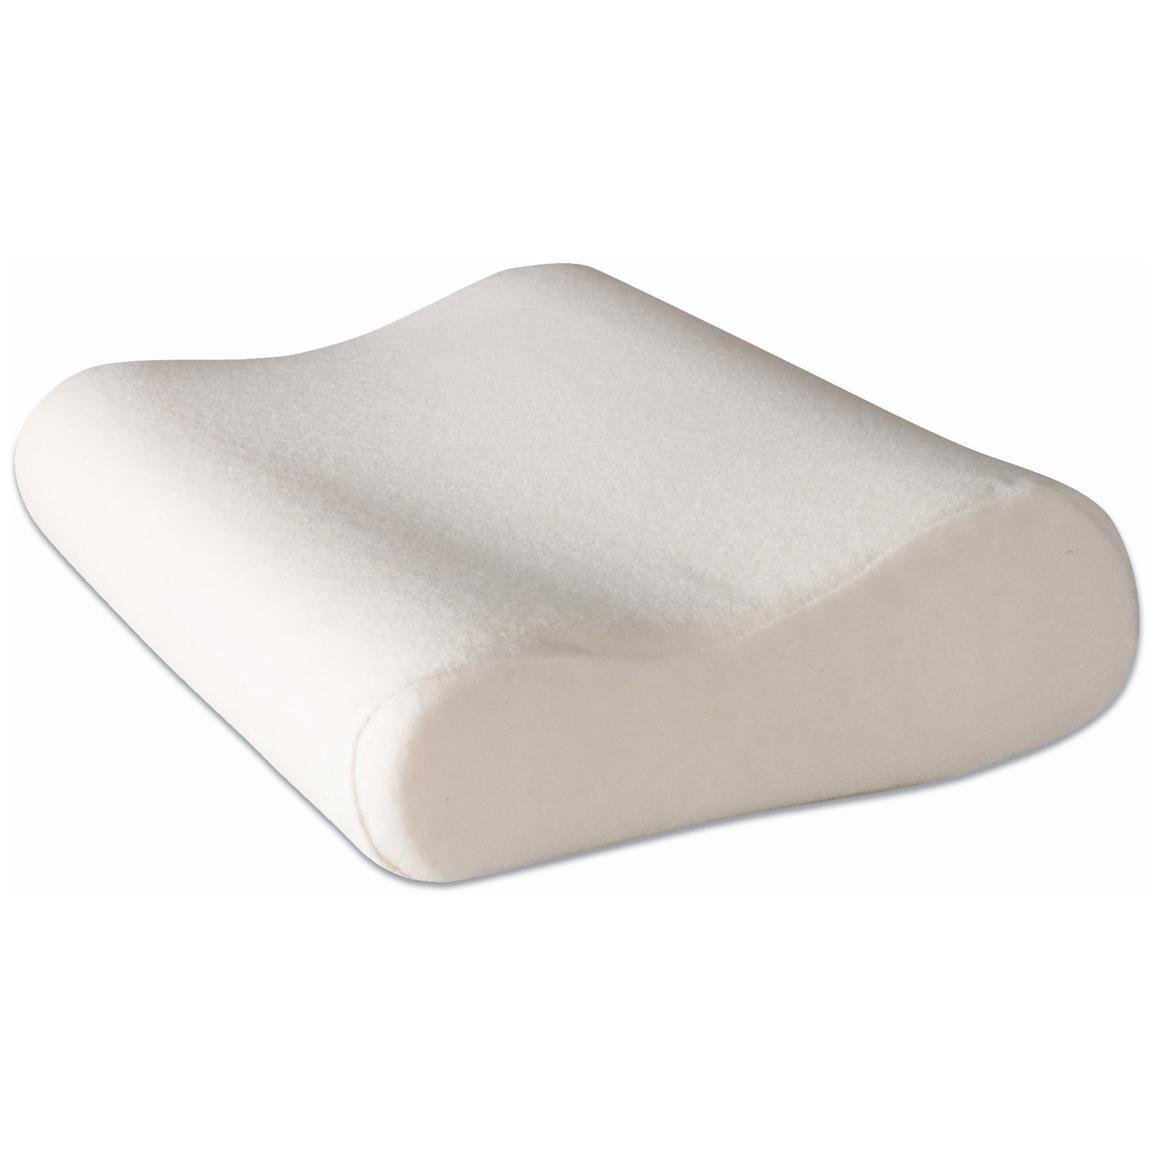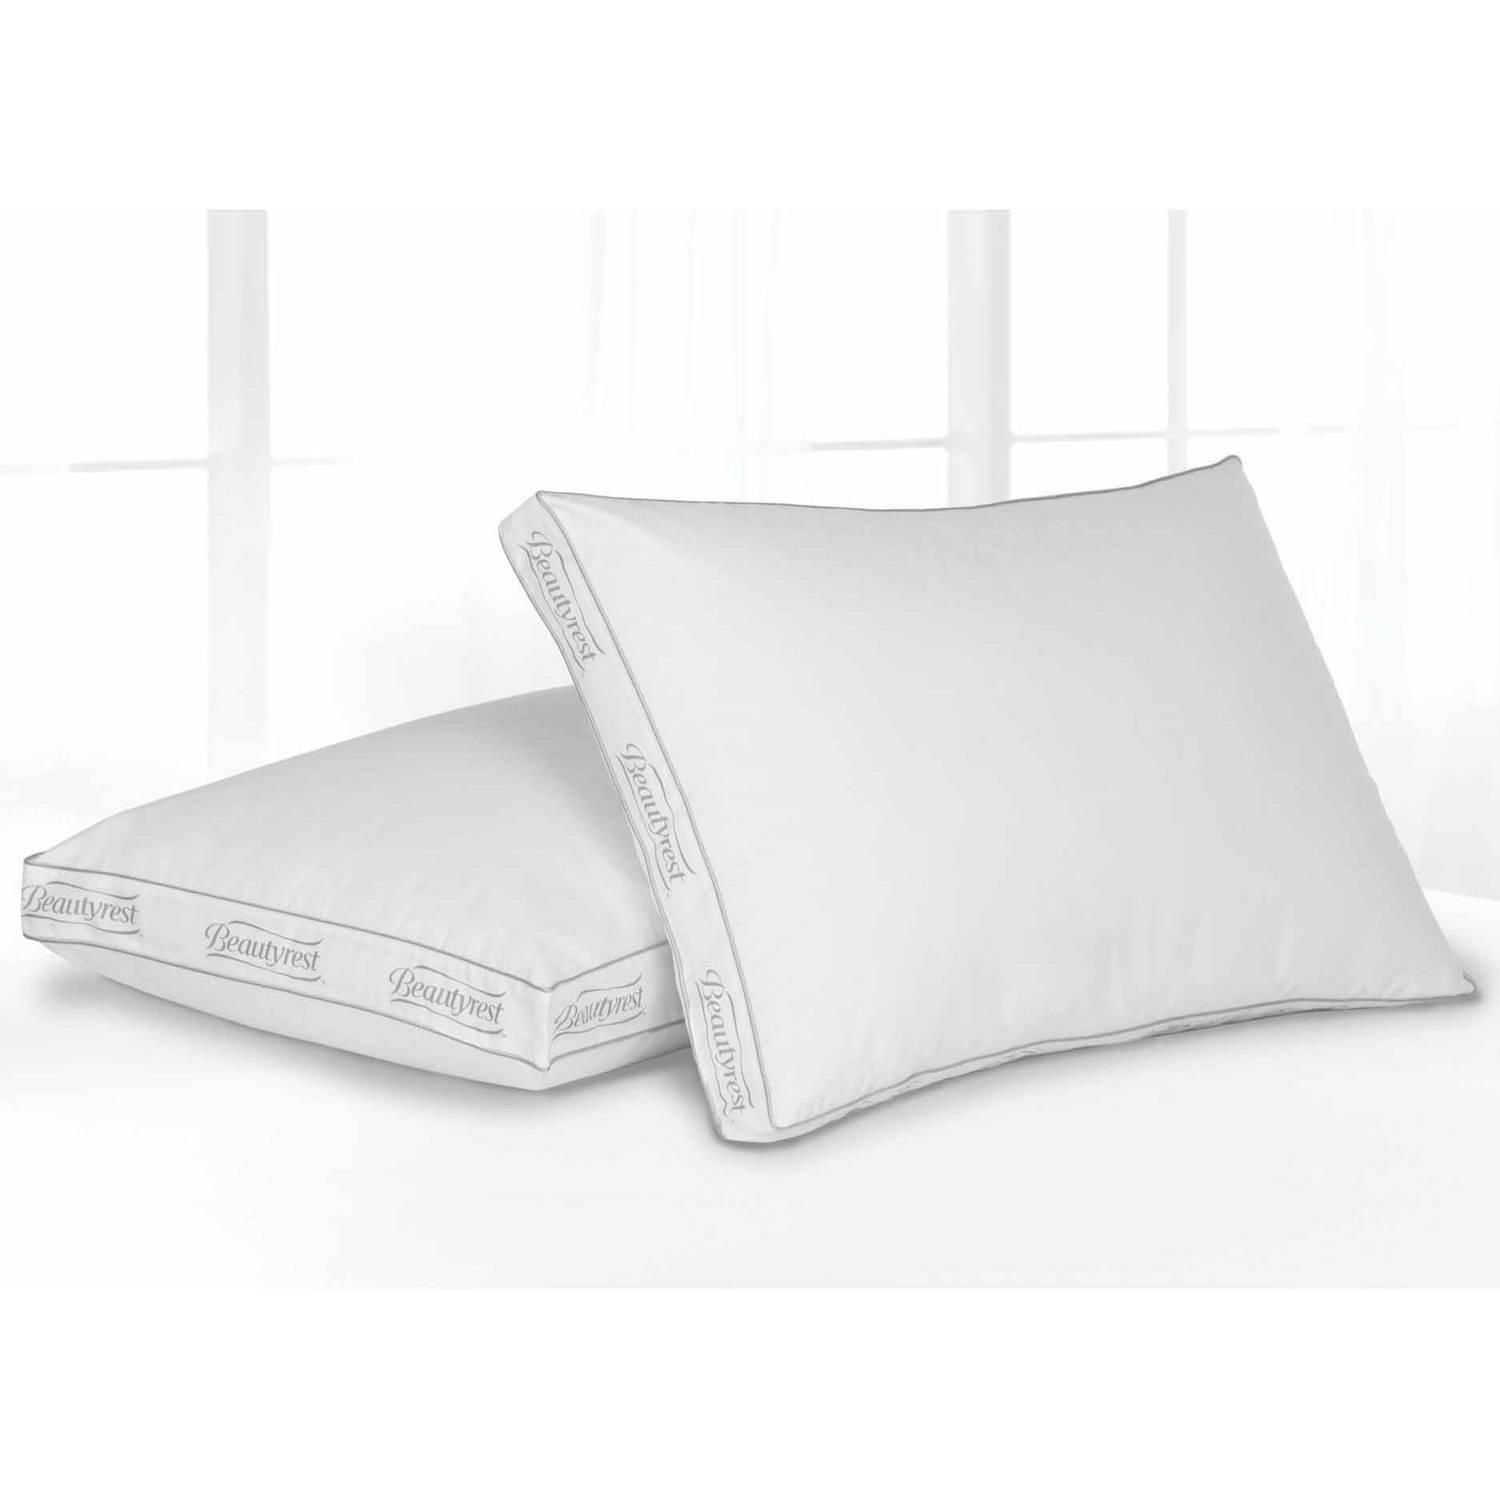The first image is the image on the left, the second image is the image on the right. Considering the images on both sides, is "An image includes a sculpted pillow with a depression for the sleeper's neck." valid? Answer yes or no. Yes. The first image is the image on the left, the second image is the image on the right. Assess this claim about the two images: "Two pillows are leaning against each other in the image on the right.". Correct or not? Answer yes or no. Yes. 